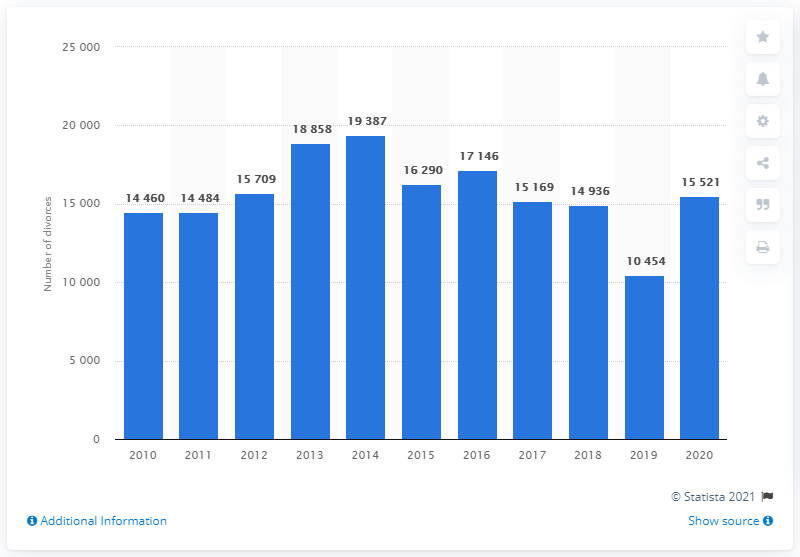Draw attention to some important aspects in this diagram. In 2014, there were 18,858 divorces in Denmark. In 2021, there were 15,521 divorces in Denmark, with a breakdown of 8,260 divorces between men and women, and 7,261 divorces between women. 